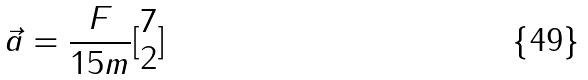Convert formula to latex. <formula><loc_0><loc_0><loc_500><loc_500>\vec { a } = \frac { F } { 1 5 m } [ \begin{matrix} 7 \\ 2 \end{matrix} ]</formula> 